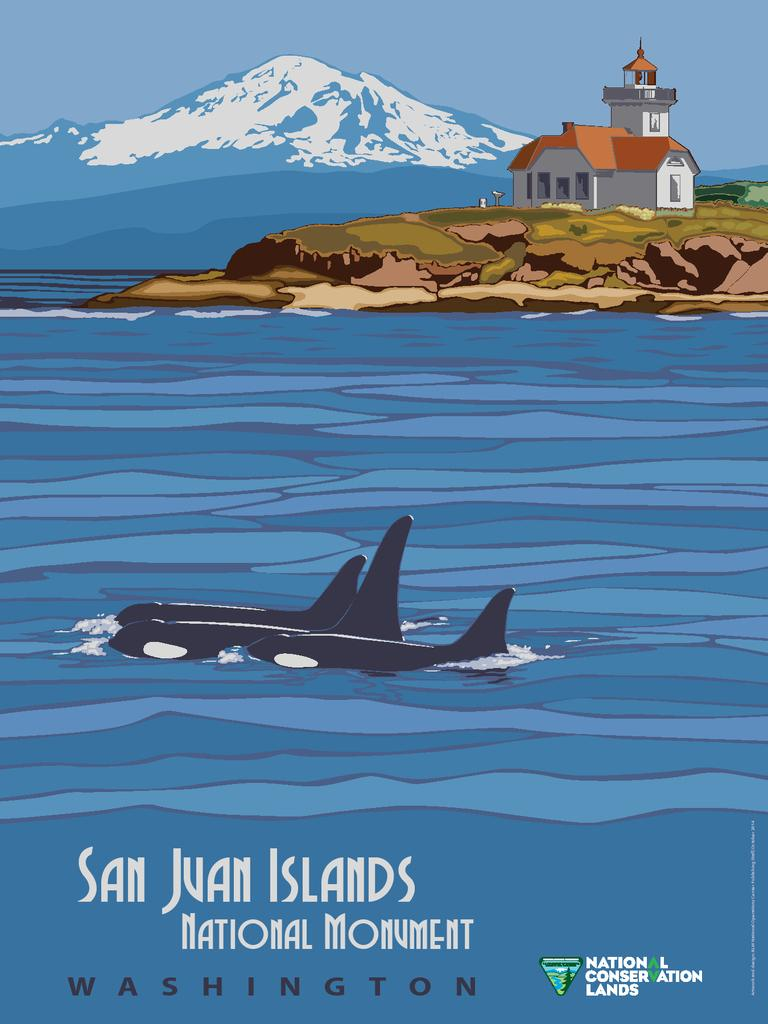<image>
Render a clear and concise summary of the photo. Ad for National Conversation Lands that show two whales swimming. 